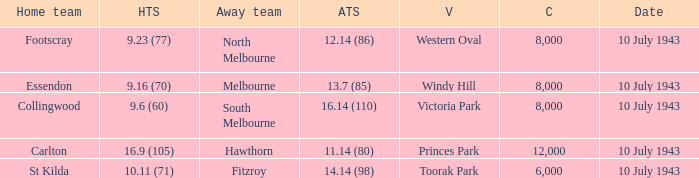When the Home team of carlton played, what was their score? 16.9 (105). 